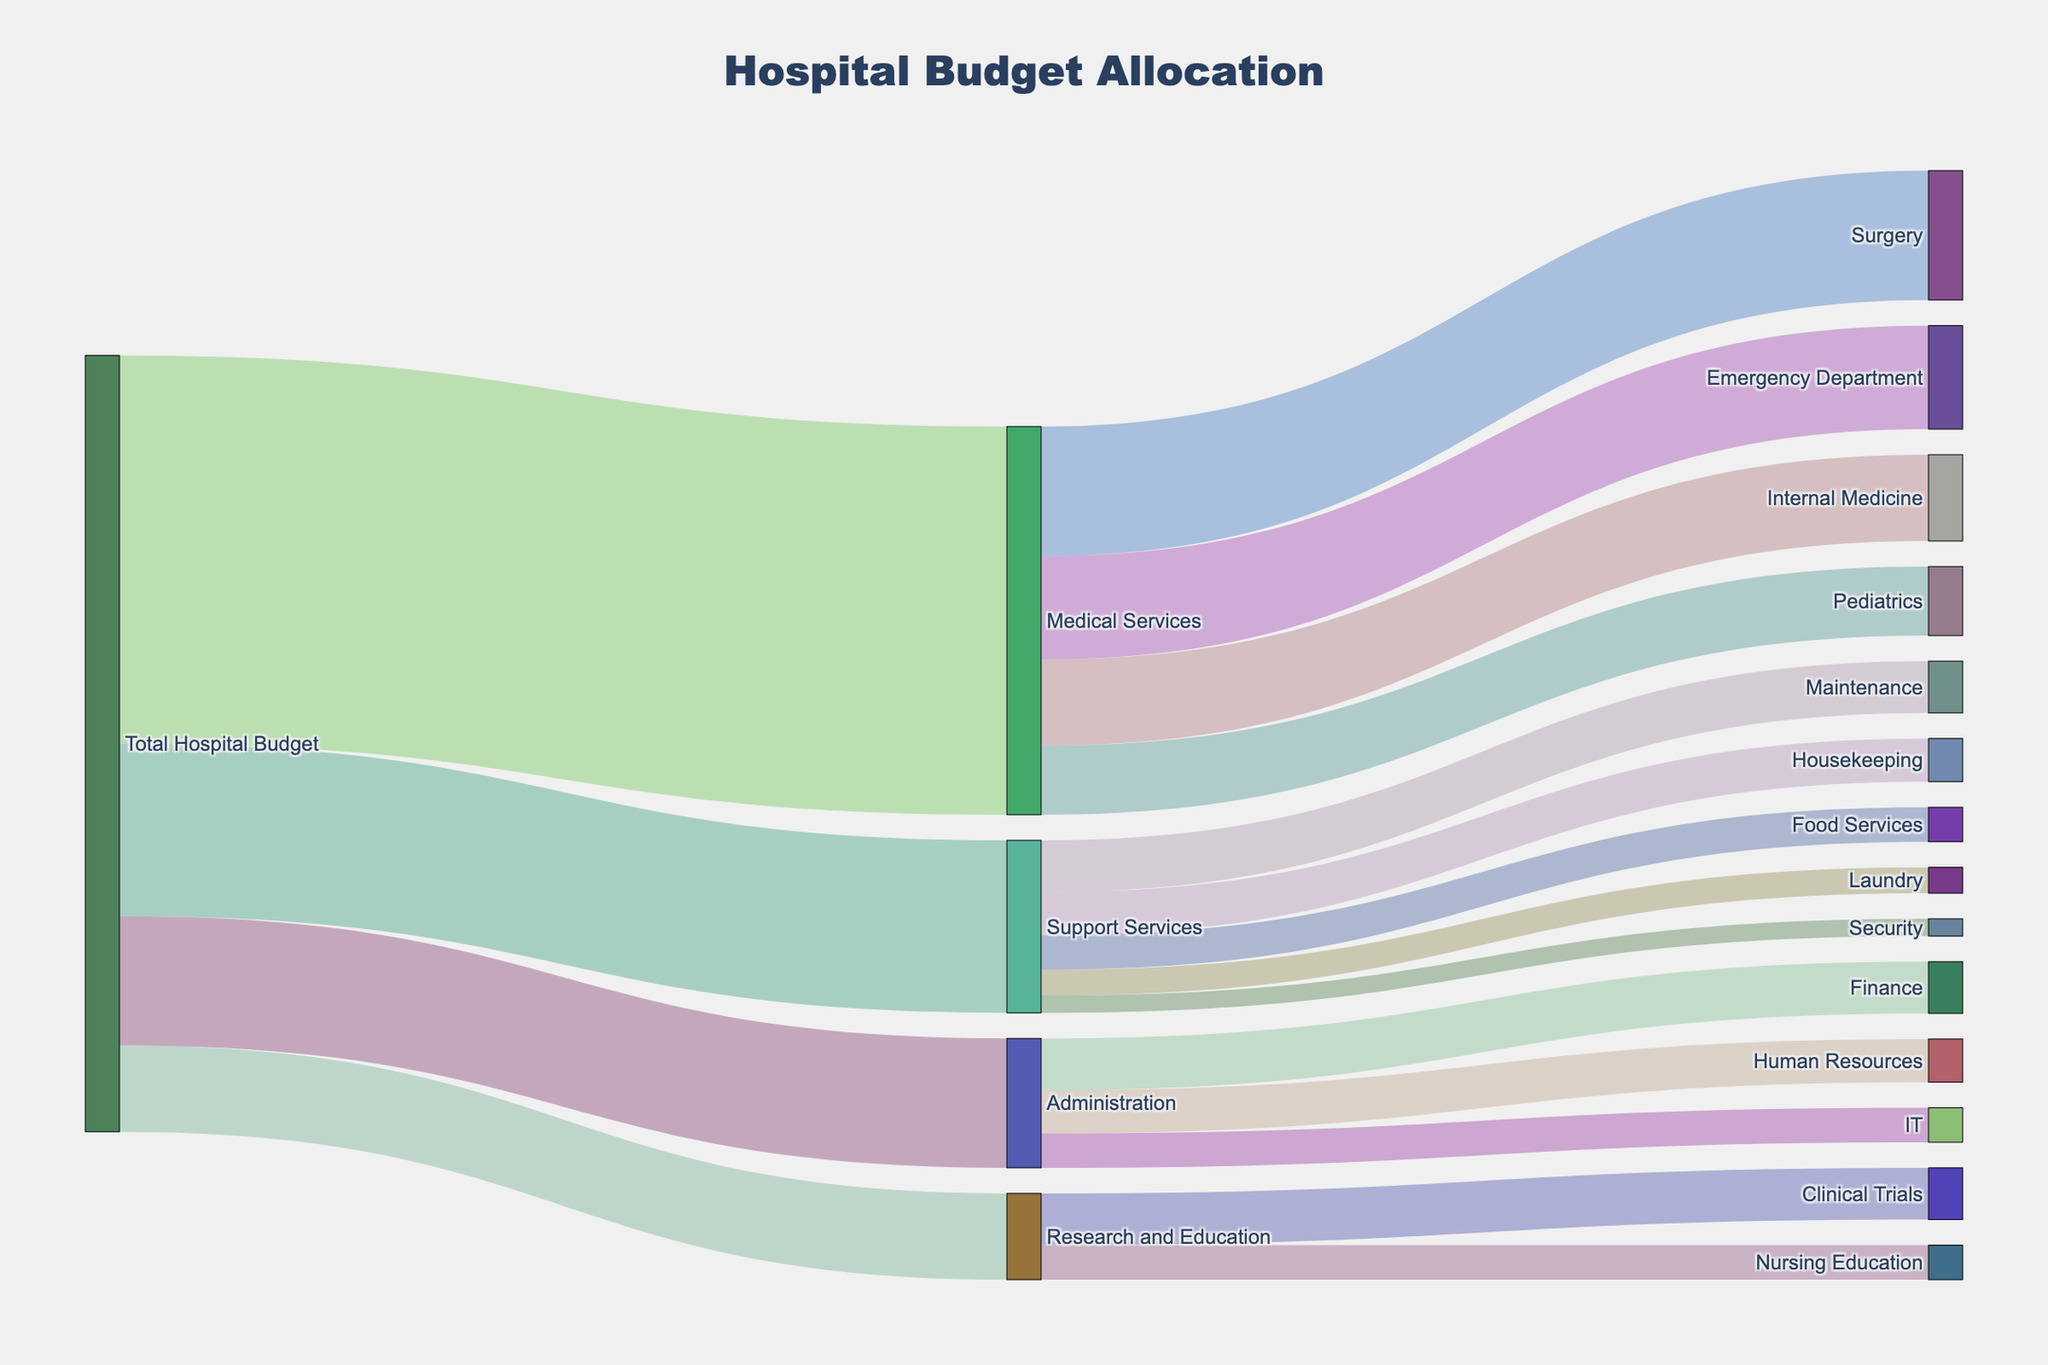what is the title of the figure? The title is typically located at the top of the figure. In this case, it reads "Hospital Budget Allocation."
Answer: Hospital Budget Allocation Which department received the highest allocation from the Total Hospital Budget? By following the connections from "Total Hospital Budget," we can see that "Medical Services" received the highest allocation amounting to 45,000,000.
Answer: Medical Services How much budget was allocated to the Administration department? Trace the link from "Total Hospital Budget" to "Administration" to find the allocated amount, which is 15,000,000.
Answer: 15,000,000 Which department under Medical Services received the least budget, and how much? Trace all connections from "Medical Services" and look for the smallest value. "Pediatrics" received the least budget with 8,000,000.
Answer: Pediatrics, 8,000,000 Compare the budget allocated to Human Resources and Finance within the Administration department. Which one received more? Trace both "Human Resources" and "Finance" links from "Administration" and compare their values: Human Resources received 5,000,000, and Finance received 6,000,000. Finance received more.
Answer: Finance What is the combined budget for the support services "Housekeeping" and "Laundry"? Trace the budget allocations to "Housekeeping" and "Laundry" under "Support Services." Adding these amounts: Housekeeping (5,000,000) + Laundry (3,000,000) = 8,000,000.
Answer: 8,000,000 Which service under Support Services received the highest budget allocation? Follow each link from "Support Services" and compare the values. "Maintenance" received the highest budget amounting to 6,000,000.
Answer: Maintenance How much budget was allocated to Nursing Education under Research and Education? Trace the link from "Research and Education" to "Nursing Education" to find the allocated amount, which is 4,000,000.
Answer: 4,000,000 What is the total budget allocated to all departments under Medical Services? Sum the budget allocations under "Medical Services": Emergency Department (12,000,000) + Surgery (15,000,000) + Internal Medicine (10,000,000) + Pediatrics (8,000,000) = 45,000,000.
Answer: 45,000,000 Is the budget for Clinical Trials higher or lower than the budget for Internal Medicine? Compare the values for "Clinical Trials" (6,000,000) and "Internal Medicine" (10,000,000). Clinical Trials has a lower budget.
Answer: Lower 